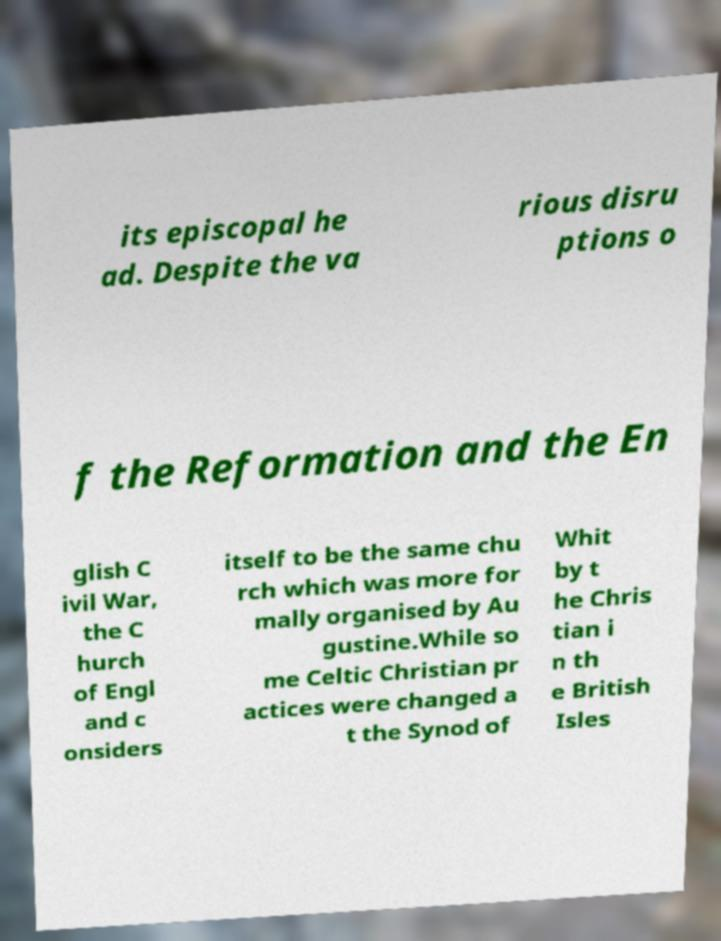There's text embedded in this image that I need extracted. Can you transcribe it verbatim? its episcopal he ad. Despite the va rious disru ptions o f the Reformation and the En glish C ivil War, the C hurch of Engl and c onsiders itself to be the same chu rch which was more for mally organised by Au gustine.While so me Celtic Christian pr actices were changed a t the Synod of Whit by t he Chris tian i n th e British Isles 